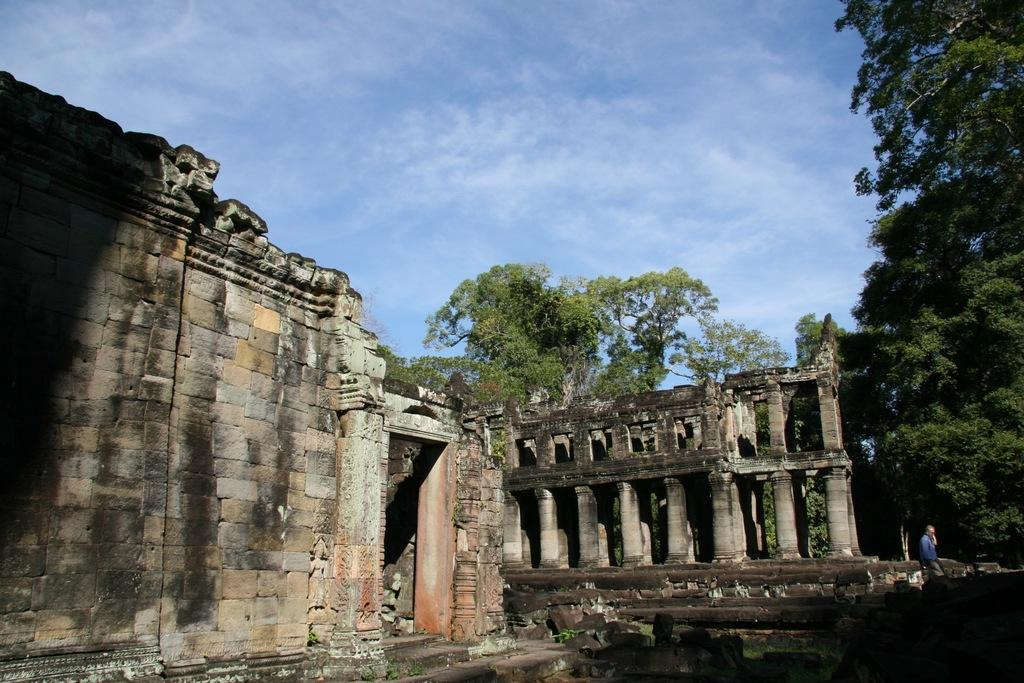What type of structures are visible in the image? There are old buildings in the image. What other natural elements can be seen in the image? There are trees and leaves visible in the image. Can you describe the person in the image? There is a person walking in the image. What is visible in the sky in the image? There are clouds in the sky in the image. What type of hook can be seen hanging from the tree in the image? There is no hook present in the image; it features old buildings, trees, leaves, a person walking, and clouds in the sky. What kind of music is the band playing in the image? There is no band present in the image; it features old buildings, trees, leaves, a person walking, and clouds in the sky. 